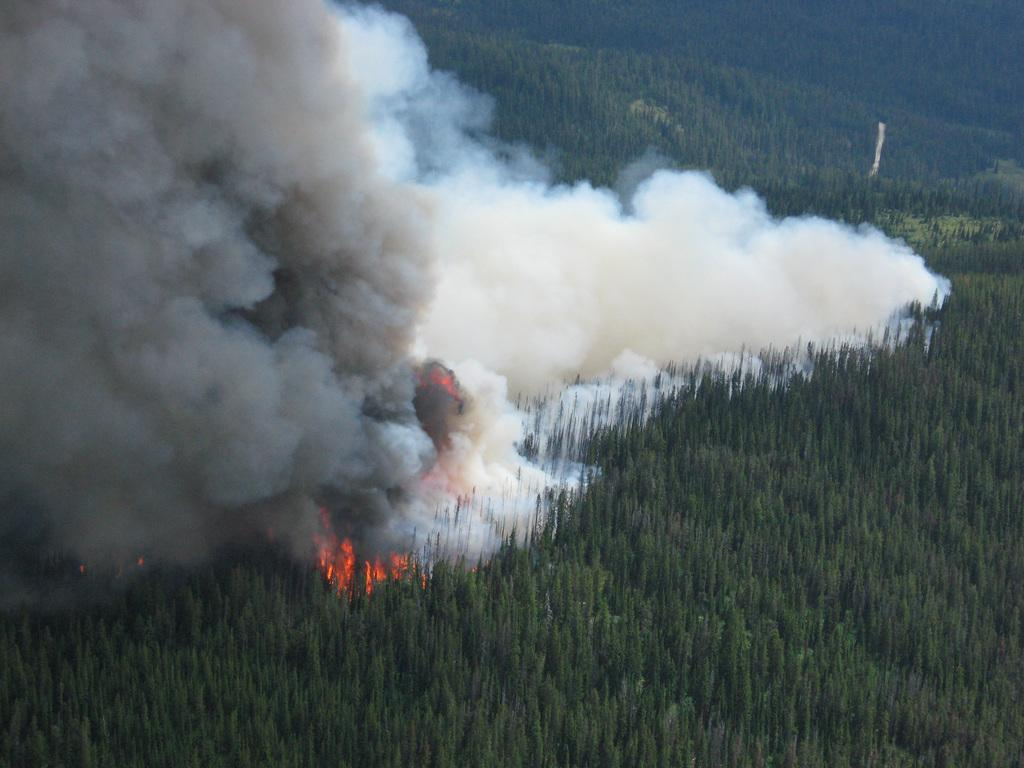What type of vegetation can be seen in the image? There are trees in the image. What is happening to some of the trees in the image? Some trees are on fire in the image. What is a result of the trees being on fire in the image? There is smoke visible in the image. What type of current can be seen flowing through the trees in the image? There is no current visible in the image; it is focused on trees and smoke. 